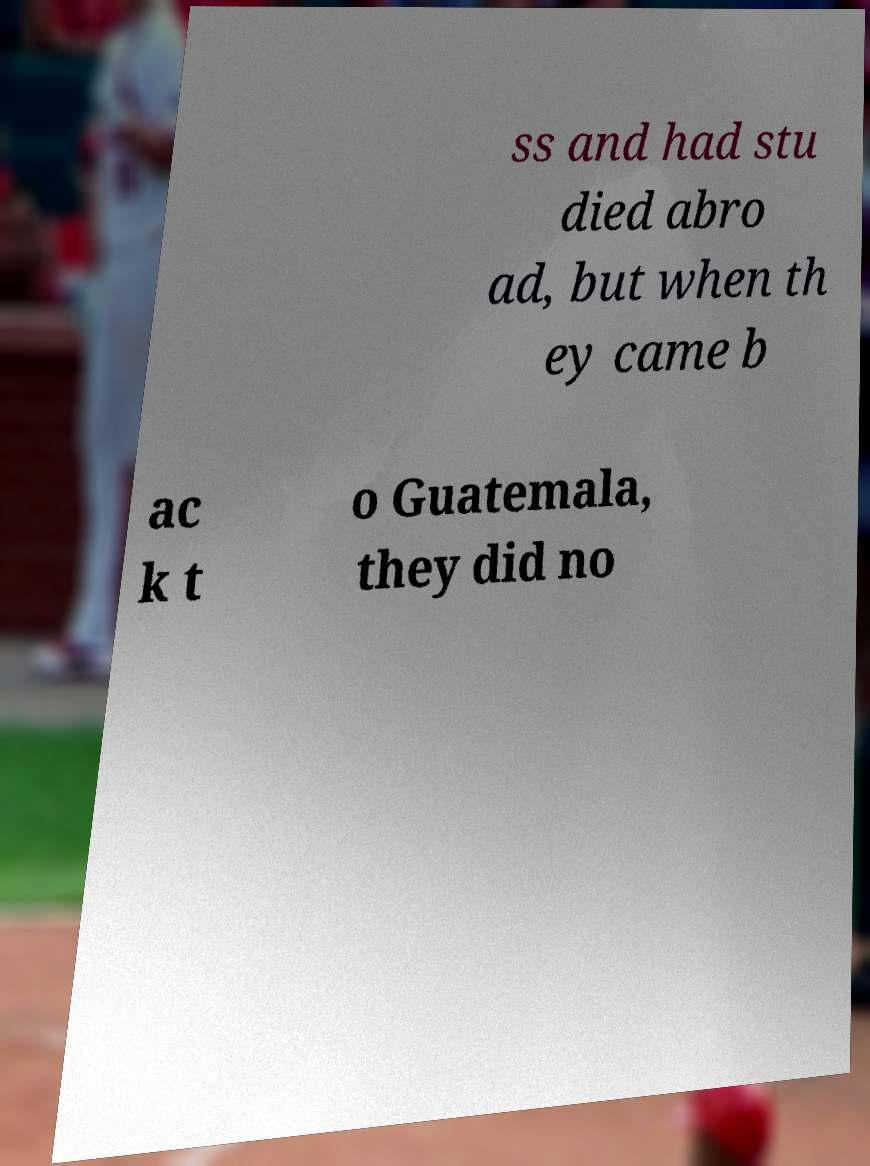Please read and relay the text visible in this image. What does it say? ss and had stu died abro ad, but when th ey came b ac k t o Guatemala, they did no 